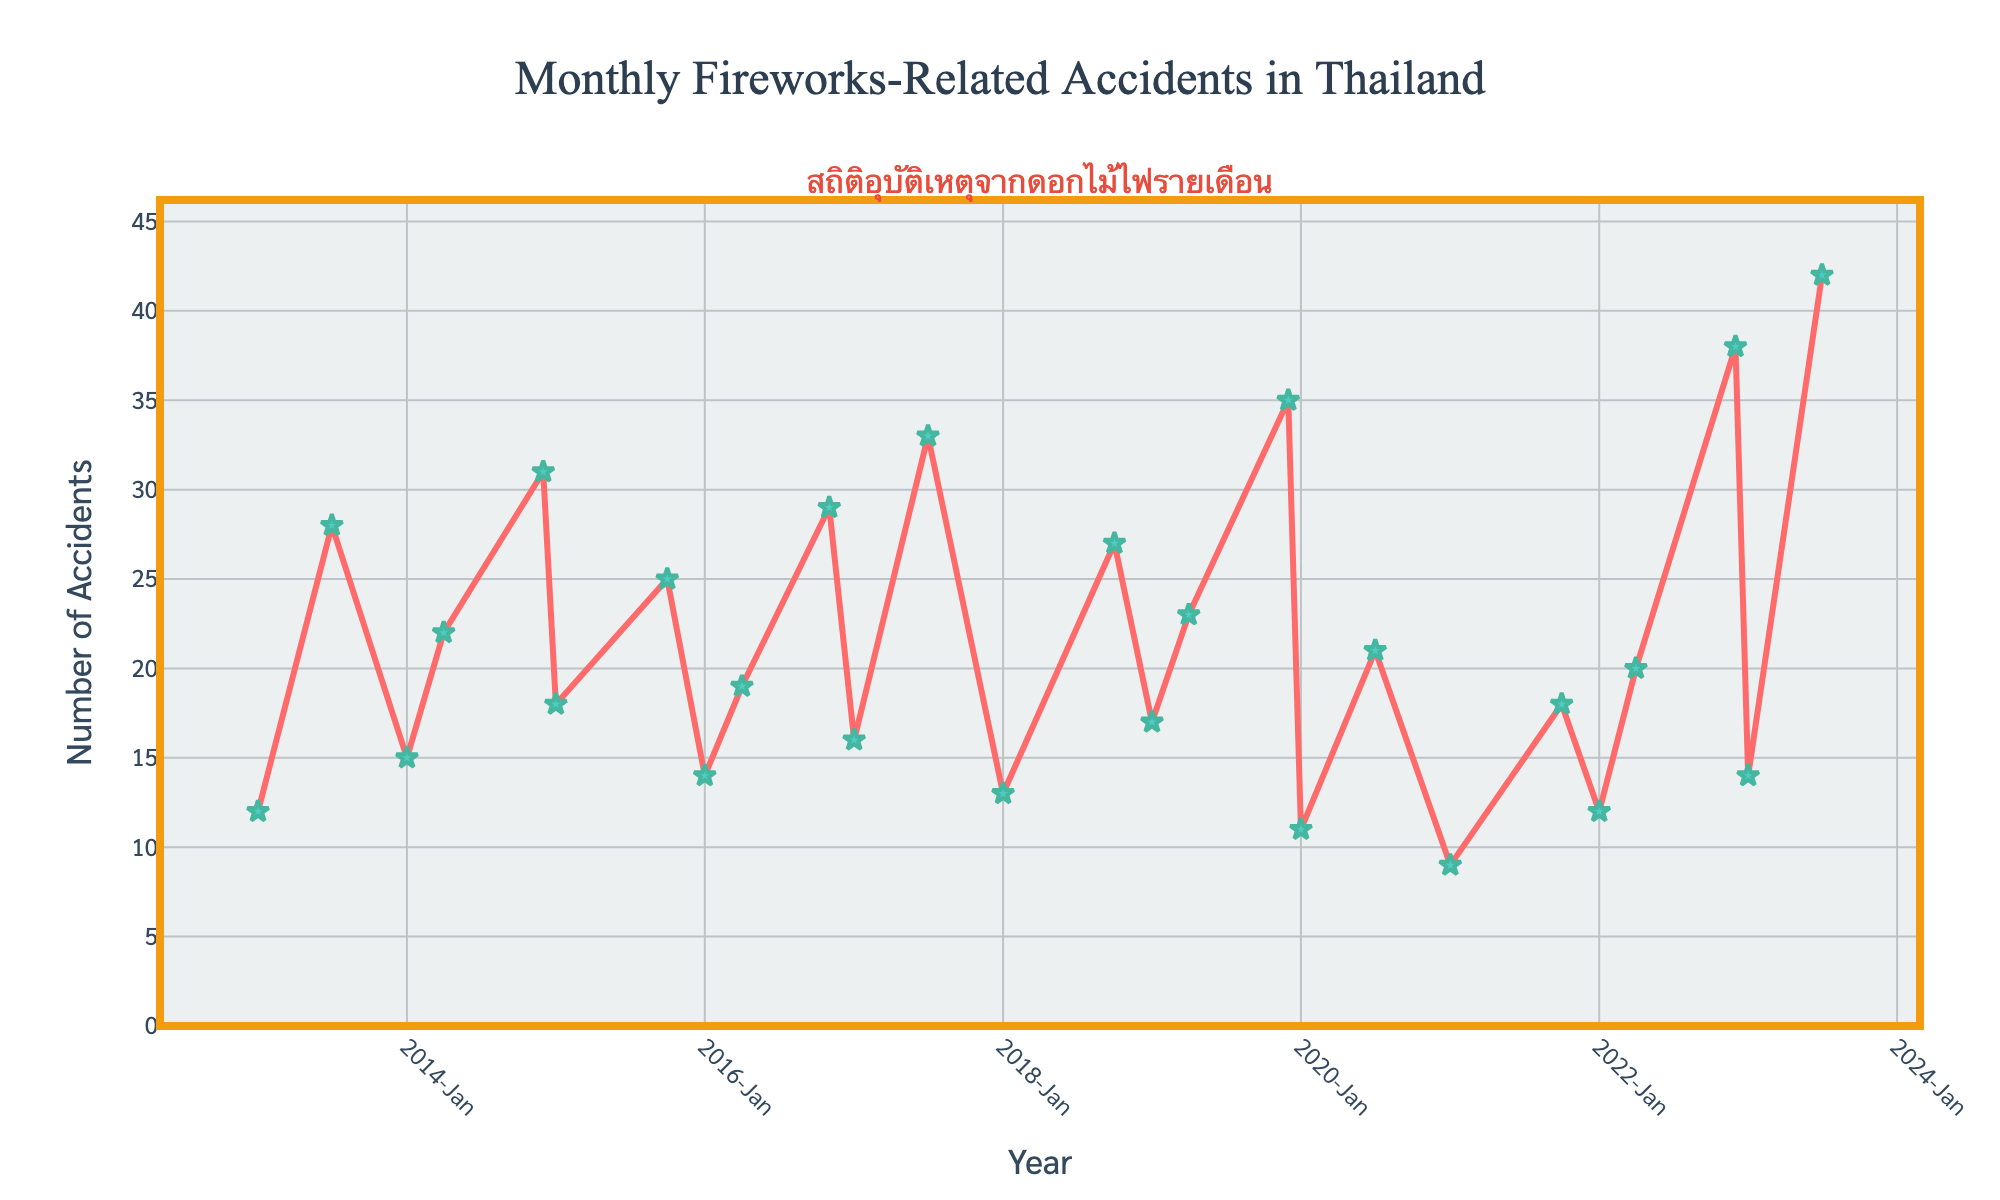What's the highest number of fireworks-related accidents recorded in a single month? Look at the highest peak in the chart. The highest peak corresponds to December 2022 with 38 accidents.
Answer: 38 How many incidents were recorded in January across all the years? Add the number of accidents listed for January in each year from the start to the end. (12 + 15 + 18 + 14 + 16 + 13 + 17 + 11 + 9 + 12 + 14) = 151.
Answer: 151 Which month recorded the maximum number of accidents in 2019? Look at the points within the 2019 section of the x-axis. The highest point is in December with 35 accidents.
Answer: December Compare the accidents in the months of July and April across all years. Which month had more occurrences and what's the difference? Sum up the accidents in all Julys and all Aprils. July: (28 + 33 + 21 + 42) = 124. April: (22 + 19 + 23 + 20) = 84. The difference is 124 - 84 = 40.
Answer: July had more by 40 Was there any year where an exceptionally high number of accidents was recorded in December? Check each December; compare them to the other months. December 2022 stands out with 38 accidents, which is significantly higher than others.
Answer: Yes, December 2022 Which month showed the lowest number of accidents over the years? Identify the lowest point in the chart. The lowest point corresponds to January 2021 with 9 accidents.
Answer: January 2021 What's the average number of accidents in October over the years where data is given? Four October values are given: (25 + 27 + 18) = 70. Their average is 70 / 3 = 23.33
Answer: 23.33 Is there a visible trend in accident numbers during January over the years? Analyze the January points from left to right in the chart. The numbers fluctuate without a clear upward or downward trend, indicating variability.
Answer: No clear trend Compare the accident trends during the months of January and December. Which has more obvious peaks? Observe the high points for both months across years. December consistently has higher peaks, especially in 2014, 2019, and 2022.
Answer: December Are the accident numbers in November relatively high or low compared to other months? Only one November point is given: 29 in 2016. Comparing to the bulk of data, 29 seems moderate, not consistently high or low.
Answer: Moderate 